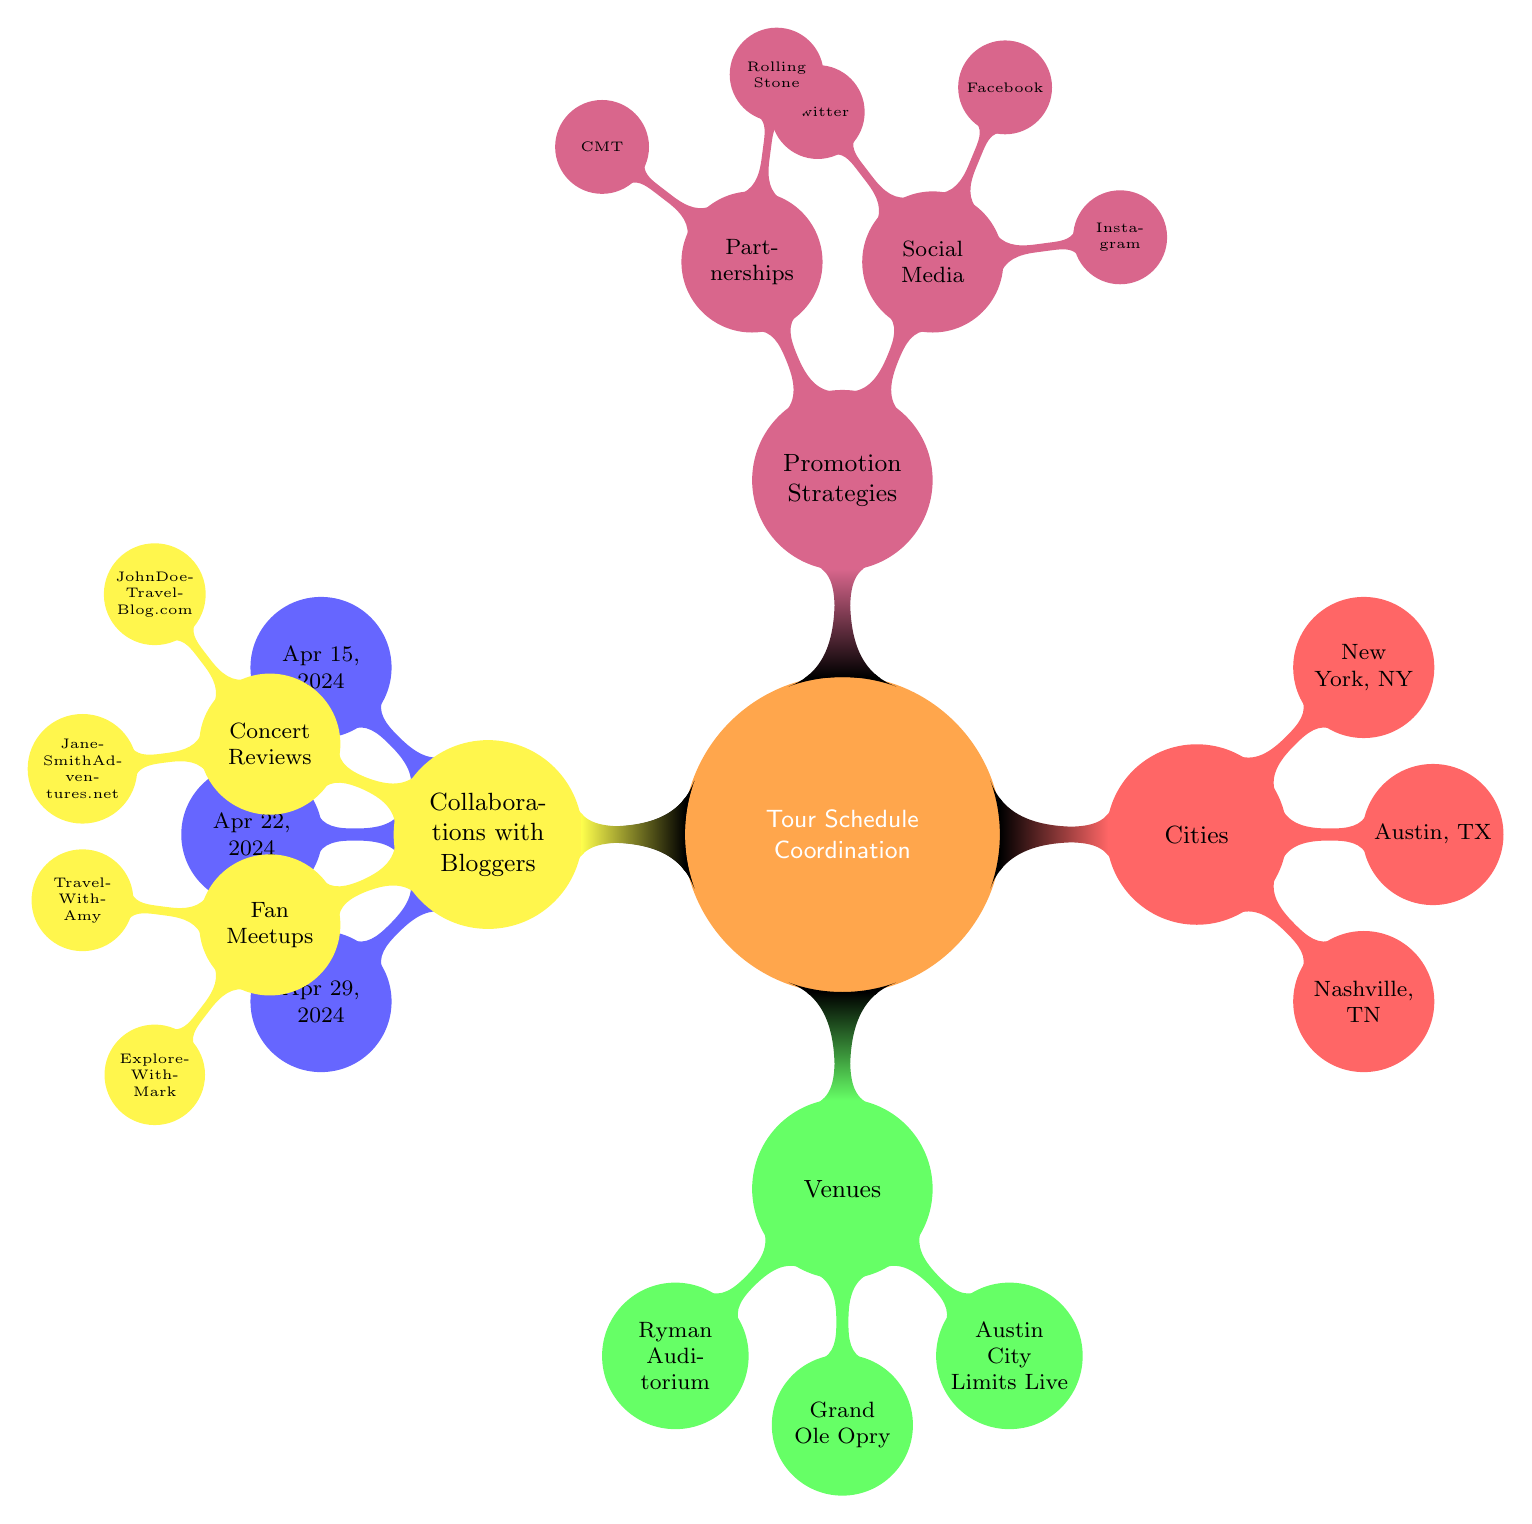What are the dates of the tour? The diagram lists three specific dates under the "Tour Dates" node. These are April 15, April 22, and April 29, 2024.
Answer: April 15, April 22, April 29 How many venues are listed? The "Venues" node identifies three performance locations, which are the Ryman Auditorium, Grand Ole Opry, and Austin City Limits Live. Counting these gives a total of three venues.
Answer: 3 Which city hosts the Grand Ole Opry? By examining the "Venues" node and identifying the Grand Ole Opry, we can trace it back to the "Cities" node, where Nashville, TN is listed as the hosting city.
Answer: Nashville, TN What are the social media platforms mentioned? The "Promotion Strategies" section includes a sub-node for "Social Media." Here, Instagram, Facebook, and Twitter are listed as the platforms, which can be directly summarized.
Answer: Instagram, Facebook, Twitter Which partner is associated with a feature article? Under the "Promotion Strategies," there’s a sub-node for "Partnerships." Among these, Rolling Stone is specifically mentioned for its strategy of a feature article.
Answer: Rolling Stone How many bloggers are listed for concert reviews? The "Collaborations with Bloggers" node includes a sub-node for "Concert Reviews," where two bloggers, JohnDoeTravelBlog.com and JaneSmithAdventures.net, are mentioned. Hence, the count of bloggers is two.
Answer: 2 What kind of strategy is associated with CMT? In the "Promotion Strategies" section, under "Partnerships," CMT is associated with the strategy of a television interview, making it clear what role they play.
Answer: Television Interview Which blogger is associated with fan meetups? Under the "Collaborations with Bloggers" section, the "Fan Meetups" sub-node lists two bloggers, TravelWithAmy and ExploreWithMark. Both facilitate these meetups, but only one needs to be named, so either could be appropriate.
Answer: TravelWithAmy What is the relationship between venues and cities? The diagram demonstrates a direct relationship where each venue is located in a specific city listed under the "Cities" node, establishing a clear connection.
Answer: Direct relationship 